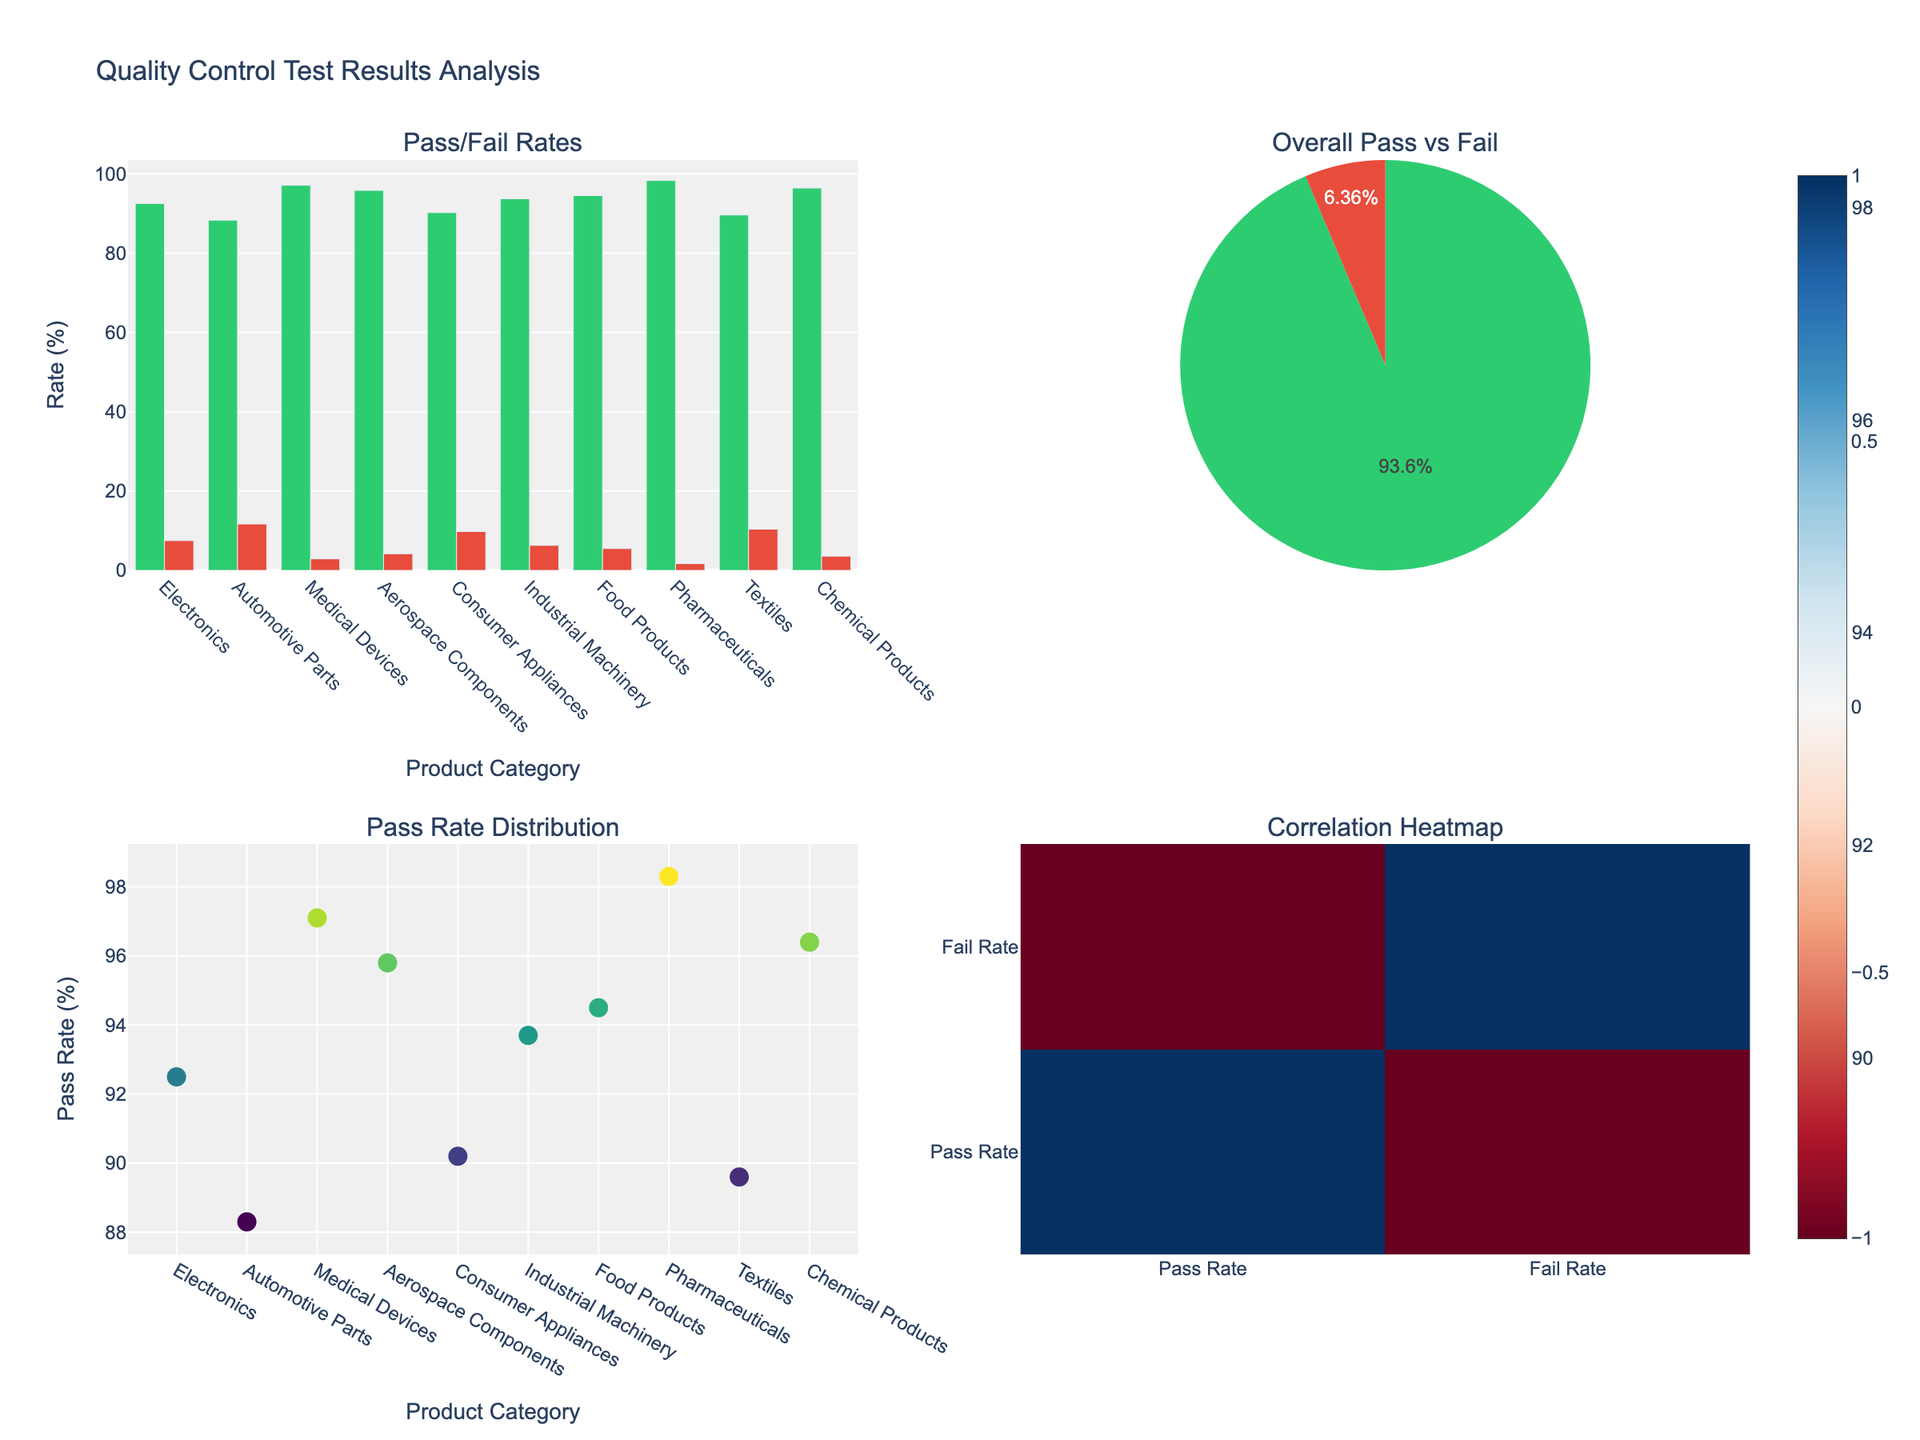How many states and territories are displayed in the figure? Count the number of bars on the x-axis for any of the subplots. There are 8 different states and territories shown.
Answer: 8 Which state has the highest number of rugby clubs? Look at the first subplot titled "Rugby Clubs" and find the state with the tallest bar. New South Wales has the highest number of rugby clubs.
Answer: New South Wales What is the total number of training facilities in Victoria and Queensland combined? Locate the bars for Victoria and Queensland in the second subplot titled "Training Facilities" and sum their values, 80 + 155 = 235.
Answer: 235 How many more stadiums are there in New South Wales compared to Tasmania? Find the values for New South Wales and Tasmania in the third subplot titled "Stadiums" and subtract Tasmania’s value from New South Wales: 25 - 3 = 22.
Answer: 22 Which state or territory has the fewest training facilities? Identify the shortest bar in the second subplot titled "Training Facilities." Northern Territory has the fewest training facilities.
Answer: Northern Territory Compare the number of rugby clubs in Queensland and New South Wales. Which one has more, and by how much? Find the values for Queensland and New South Wales in the first subplot. Queensland has 185 clubs, and New South Wales has 215 clubs. Subtract Queensland's value from New South Wales': 215 - 185 = 30.
Answer: New South Wales by 30 What is the average number of stadiums across all states and territories? Sum the number of stadiums for all states and territories from the third subplot: 25 + 20 + 12 + 8 + 5 + 3 + 4 + 2 = 79. Then, divide by the number of states and territories, 79 / 8.
Answer: 9.875 Which states or territories have an equal number of stadiums? Look at the values in the third subplot and find where they are the same. Australian Capital Territory and South Australia both have 4 stadiums.
Answer: Australian Capital Territory and South Australia Rank the states and territories by the number of training facilities from highest to lowest. Observe the second subplot titled "Training Facilities" and list the states and territories in decreasing order: New South Wales, Queensland, Victoria, Western Australia, South Australia, Australian Capital Territory, Tasmania, Northern Territory.
Answer: New South Wales, Queensland, Victoria, Western Australia, South Australia, Australian Capital Territory, Tasmania, Northern Territory What is the difference between the number of rugby clubs in Victoria and the number of training facilities in Western Australia? Find the values for Victoria in the first subplot and Western Australia in the second subplot. Subtract the value for Western Australia from Victoria: 95 - 55 = 40.
Answer: 40 